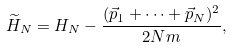<formula> <loc_0><loc_0><loc_500><loc_500>\widetilde { H } _ { N } = H _ { N } - \frac { ( \vec { p } _ { 1 } + \cdots + \vec { p } _ { N } ) ^ { 2 } } { 2 N m } ,</formula> 